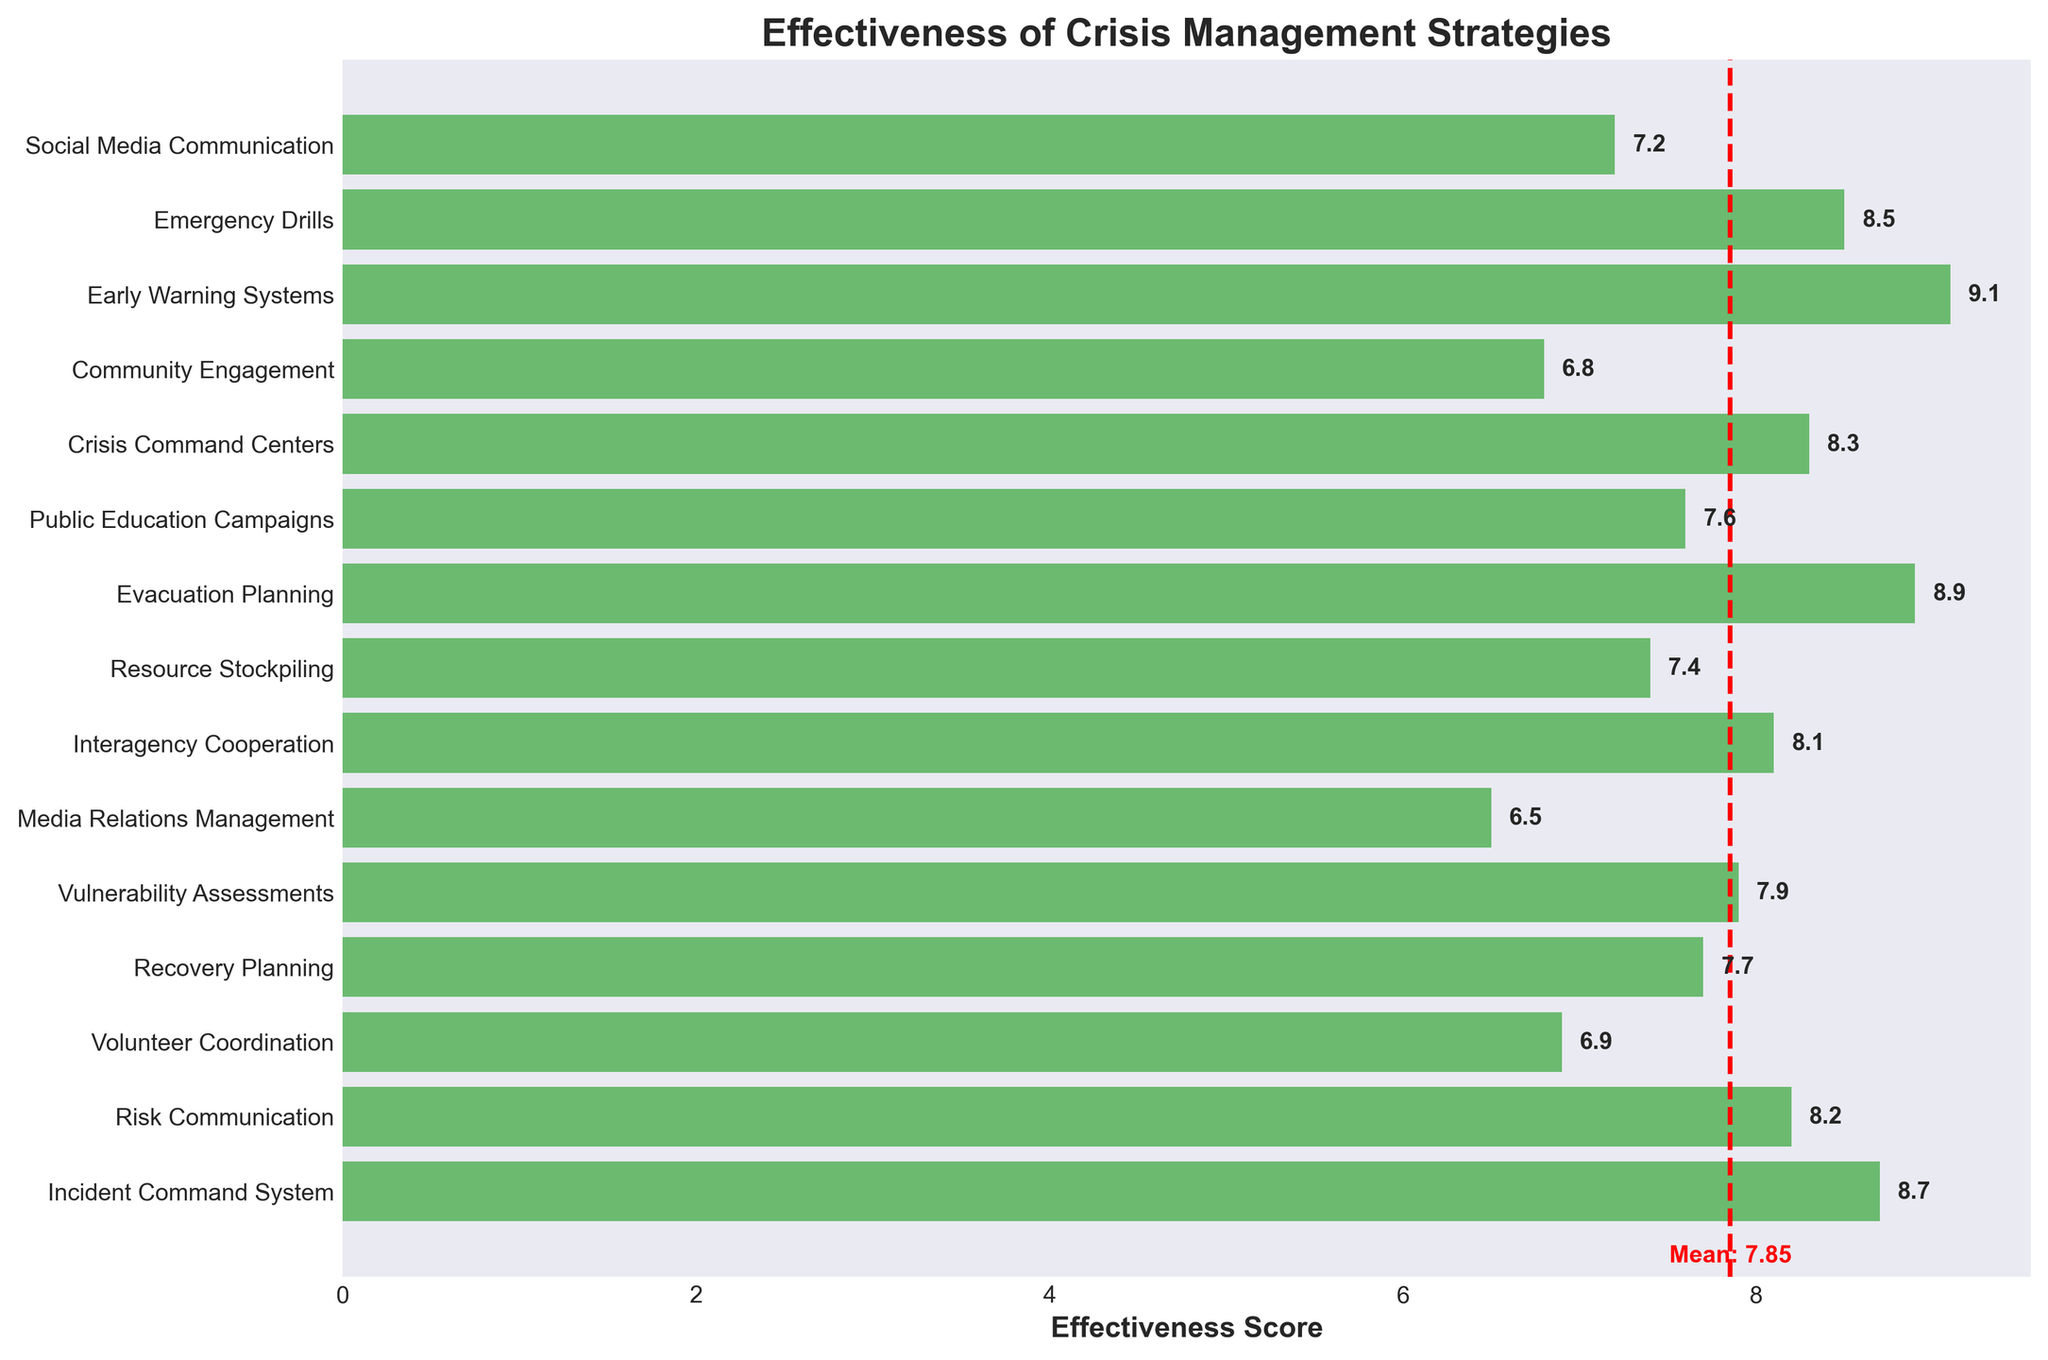What is the title of the figure? The title is located at the top of the figure. It summarizes what the chart illustrates.
Answer: Effectiveness of Crisis Management Strategies How many crisis management strategies are evaluated in the figure? Count the number of unique labels (strategies) on the y-axis. The figure features one bar per strategy.
Answer: 15 Which crisis management strategy received the highest effectiveness score? Look at the x-axis values and identify the bar that reaches the farthest to the right.
Answer: Early Warning Systems What is the mean effectiveness score, as indicated by the red vertical line? Look at where the red vertical dashed line intersects the x-axis and read the accompanying label.
Answer: 7.93 Which strategy has a lower effectiveness score than the mean? Compare each bar's length to the position of the red line; those ending before the red line are below the mean.
Answer: Community Engagement, Media Relations Management, Volunteer Coordination What is the difference in effectiveness score between the 'Emergency Drills' and the 'Recovery Planning'? Subtract the effectiveness score of 'Recovery Planning' from 'Emergency Drills'.
Answer: 0.8 How many strategies have an effectiveness score of 8 or above? Count the bars with scores of 8 or higher by looking at their lengths against the x-axis labels.
Answer: 8 What is the second highest-rated strategy? Identify the two longest bars and determine the one that is slightly shorter than the longest.
Answer: Incident Command System Which strategy has the closest effectiveness score to the mean score? Look for the bar that ends nearest the position of the red vertical dashed line.
Answer: Interagency Cooperation How does 'Media Relations Management' compare to 'Volunteer Coordination' in terms of effectiveness score? Refer to both x-axis values and compare the lengths of their corresponding bars.
Answer: Media Relations Management is less effective 